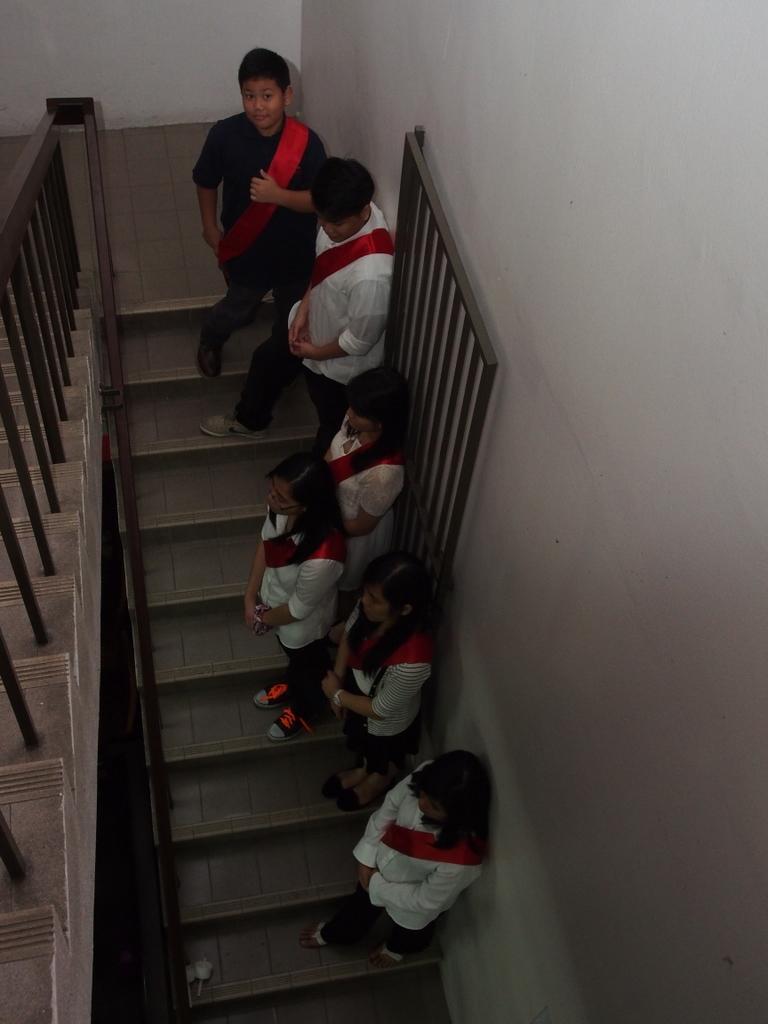Can you describe this image briefly? Here in this picture we can see a group of people standing on the stair case and all of them are carrying bags with them and on the left side we can see a railing present. 